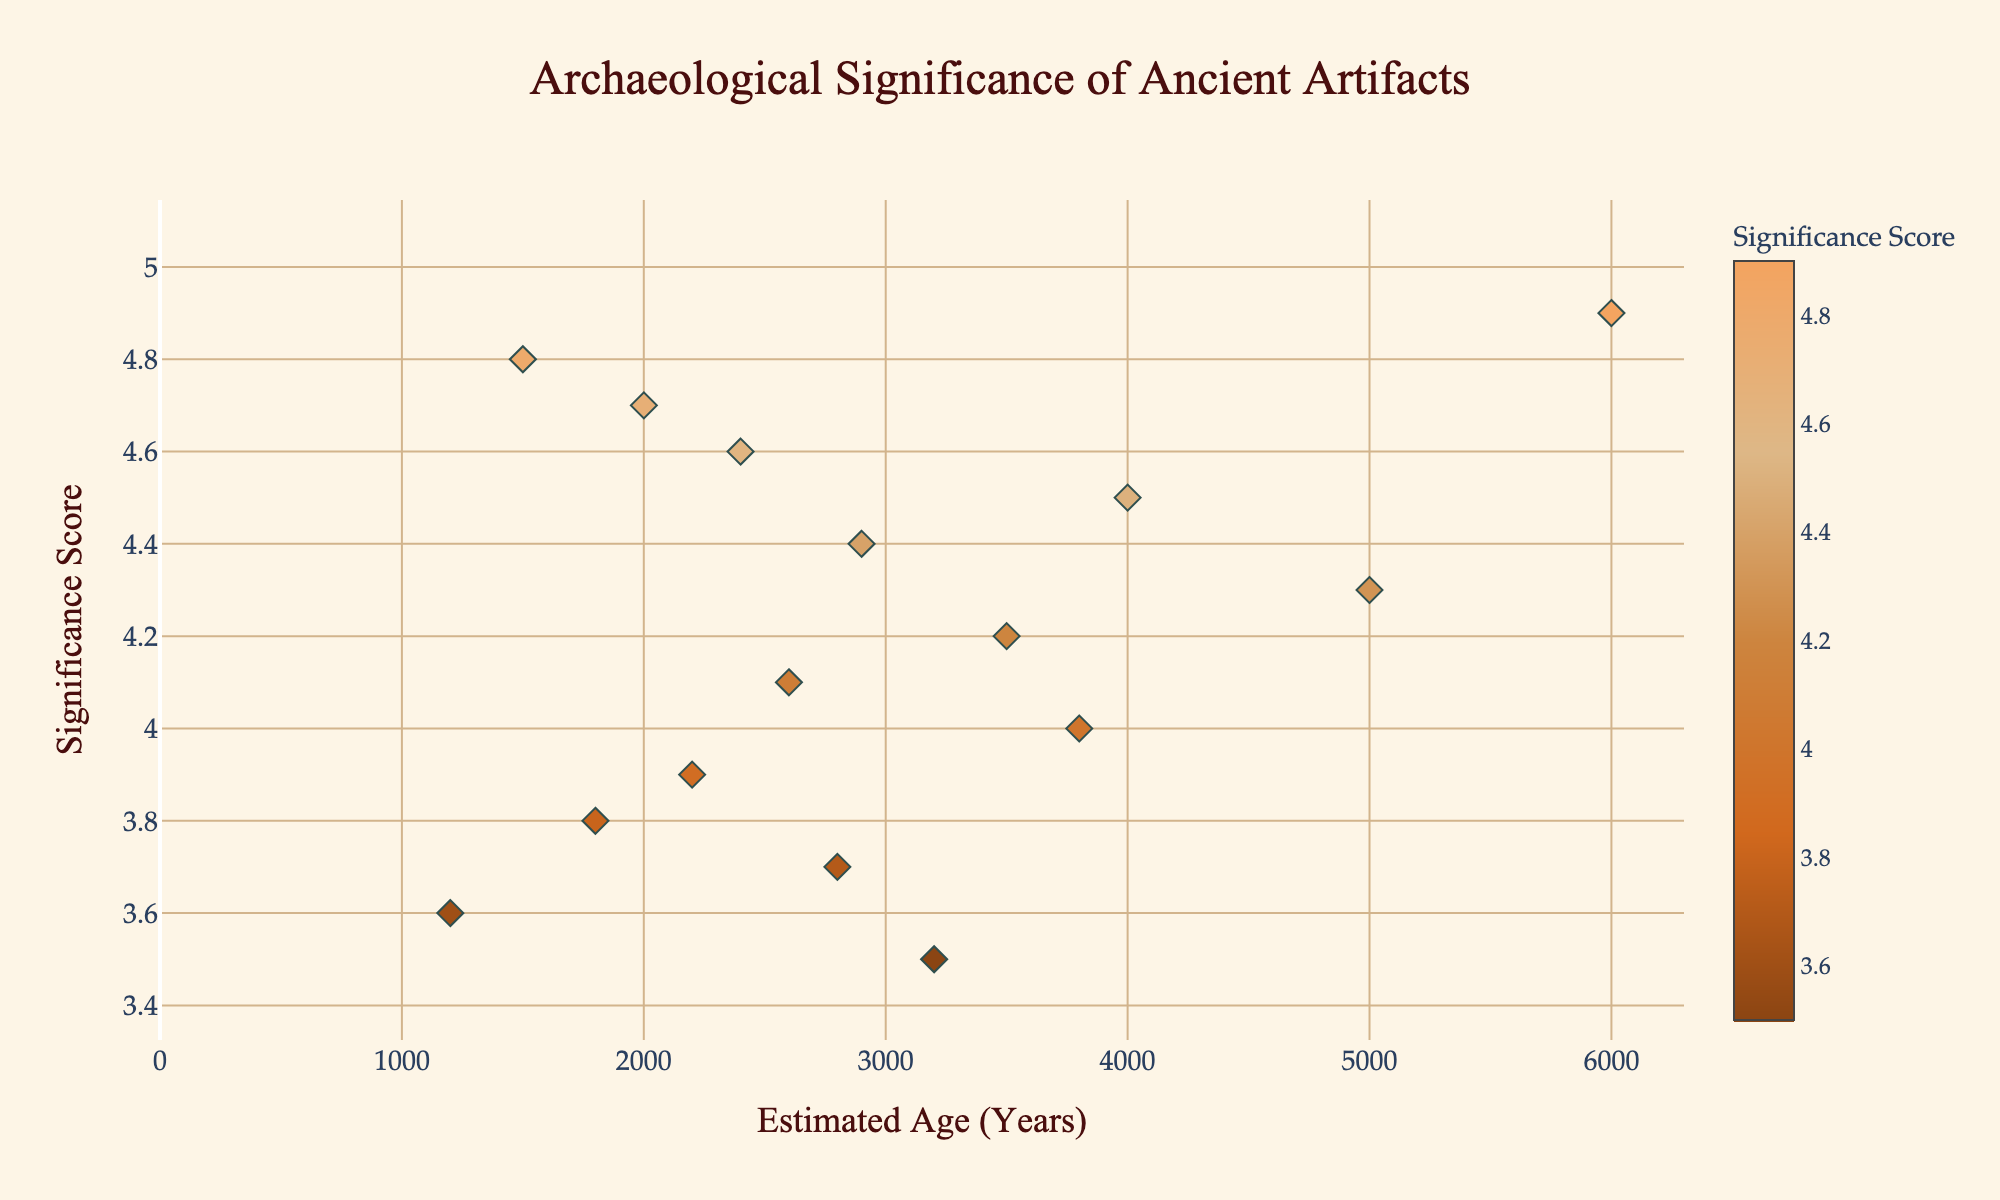What is the title of the plot? The title is displayed at the top-center of the figure in a prominent font. It is used to describe the purpose or content of the plot.
Answer: Archaeological Significance of Ancient Artifacts What is the significance score of the Cave Painting? Hovering over or locating the Cave Painting dot on the plot reveals its details. According to the data, the Cave Painting has the highest significance score.
Answer: 4.9 How many artifacts have an estimated age of over 3000 years? Check the x-axis for the data points above 3000 years and count them.
Answer: 8 Among the artifacts, which one is categorized as having the lowest significance score and what is this score? Identify the data point with the lowest y-value on the plot and refer to the hover data.
Answer: Shell Necklace, 3.5 Which artifact has the highest significance score among those aged less than 2000 years? Check the x-axis for data points below 2000 years and compare their significance scores to find the highest.
Answer: Wooden Mask, 4.8 What is the difference in significance score between the Flint Knife and the Woven Basket? Hover over or find these artifacts and subtract the significance score of the Woven Basket from the Flint Knife. Flint Knife (4.0) - Woven Basket (3.8).
Answer: 0.2 What is the average significance score of artifacts that are between 2000 and 3000 years old? Select the artifacts in the range, sum their significance scores, and divide by the number of artifacts. (4.7 + 4.6 + 3.7 + 4.1) / 4 = 4.275
Answer: 4.275 Which artifacts have the same significance score of 4.4? Locate the data points on the same y-value of 4.4 and note their hover details.
Answer: Ceremonial Staff What is the most significant artifact older than 4000 years? Look for artifacts above 4000 years on the x-axis and compare their significance scores to find the highest.
Answer: Cave Painting Which age group (i.e., below or above 2000 years) has a higher average significance score? Calculate the average significance score for artifacts aged below and above 2000 years and compare the two averages. Below 2000 years: (4.8 + 3.8 + 4.7 + 3.6) / 4 = 4.225. Above 2000 years: (4.2 + 3.7 + 3.9 + 4.5 + 3.5 + 4.1 + 4.0 + 4.6 + 4.4 + 4.3 + 4.9) / 11 = 4.109.
Answer: Below 2000 years 